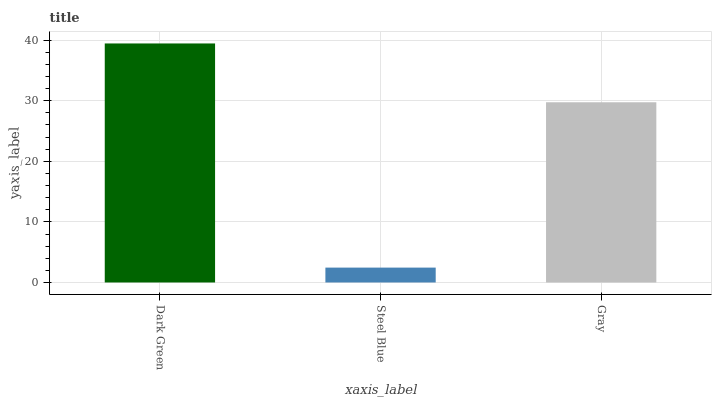Is Steel Blue the minimum?
Answer yes or no. Yes. Is Dark Green the maximum?
Answer yes or no. Yes. Is Gray the minimum?
Answer yes or no. No. Is Gray the maximum?
Answer yes or no. No. Is Gray greater than Steel Blue?
Answer yes or no. Yes. Is Steel Blue less than Gray?
Answer yes or no. Yes. Is Steel Blue greater than Gray?
Answer yes or no. No. Is Gray less than Steel Blue?
Answer yes or no. No. Is Gray the high median?
Answer yes or no. Yes. Is Gray the low median?
Answer yes or no. Yes. Is Dark Green the high median?
Answer yes or no. No. Is Dark Green the low median?
Answer yes or no. No. 